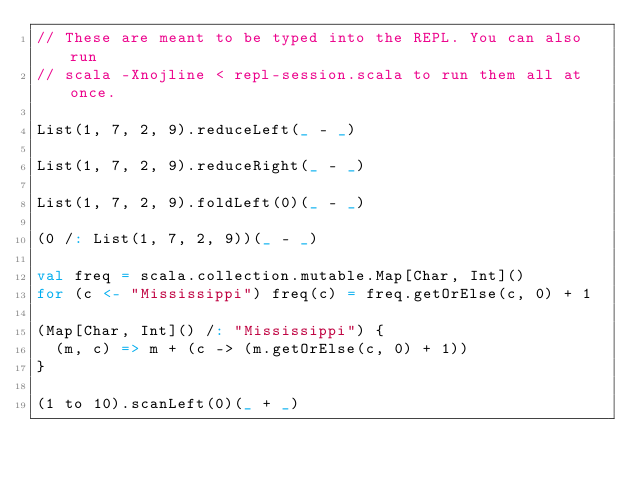<code> <loc_0><loc_0><loc_500><loc_500><_Scala_>// These are meant to be typed into the REPL. You can also run
// scala -Xnojline < repl-session.scala to run them all at once.

List(1, 7, 2, 9).reduceLeft(_ - _)

List(1, 7, 2, 9).reduceRight(_ - _)

List(1, 7, 2, 9).foldLeft(0)(_ - _)

(0 /: List(1, 7, 2, 9))(_ - _)

val freq = scala.collection.mutable.Map[Char, Int]()
for (c <- "Mississippi") freq(c) = freq.getOrElse(c, 0) + 1

(Map[Char, Int]() /: "Mississippi") {
  (m, c) => m + (c -> (m.getOrElse(c, 0) + 1))
}

(1 to 10).scanLeft(0)(_ + _)
</code> 